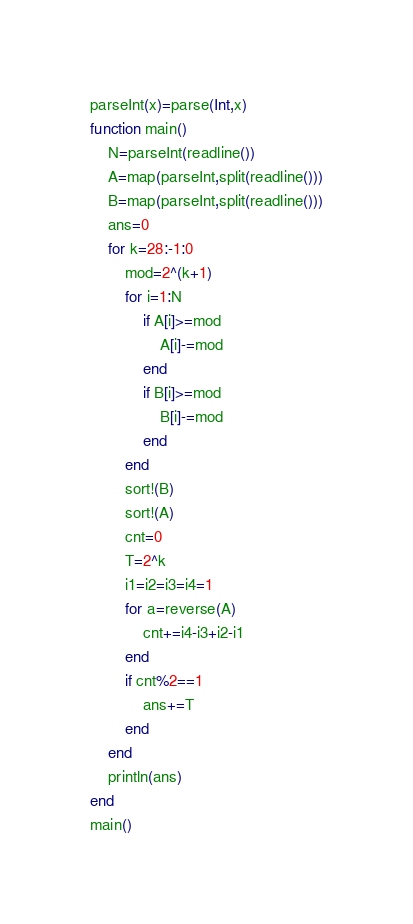Convert code to text. <code><loc_0><loc_0><loc_500><loc_500><_Julia_>parseInt(x)=parse(Int,x)
function main()
	N=parseInt(readline())
	A=map(parseInt,split(readline()))
	B=map(parseInt,split(readline()))
	ans=0
	for k=28:-1:0
		mod=2^(k+1)
		for i=1:N
			if A[i]>=mod
				A[i]-=mod
			end
			if B[i]>=mod
				B[i]-=mod
			end
		end
		sort!(B)
		sort!(A)
		cnt=0
		T=2^k
		i1=i2=i3=i4=1
		for a=reverse(A)
			cnt+=i4-i3+i2-i1
		end
		if cnt%2==1
			ans+=T
		end
	end
	println(ans)
end
main()
</code> 